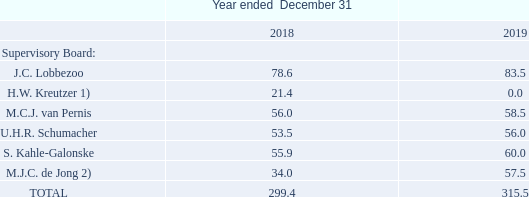SUPERVISORY BOARD
The following table sets forth information concerning all remuneration (base compensation, no bonuses or pensions were paid) from the Company (including its subsidiaries) for services in all capacities to all current and former members of the Supervisory Board of the Company:
1 Period January 1 to May 28, 2018
2 Period as of May 28, 2018
The remuneration of members of the Supervisory Board has been determined by the 2018 Annual General Meeting of Shareholders.
No stock options or performance shares have been granted to members of the Supervisory Board.
How were the remuneration figures determined? By the 2018 annual general meeting of shareholders. What does the table show? Information concerning all remuneration (base compensation, no bonuses or pensions were paid) from the company (including its subsidiaries) for services in all capacities to all current and former members of the supervisory board of the company. Who are the members of the Supervisory board? J.c. lobbezoo, h.w. kreutzer, m.c.j. van pernis, u.h.r. schumacher, s. kahle-galonske, m.j.c. de jong. In 2019, who are the members that received more than 60.0 in remuneration? For Col4 rows 4 to 9 find the values that are >60.0 and the corresponding member in col2
Answer: j.c. lobbezoo. For 2018, what is the order of the members arranged by ascending order in terms of remuneration? Sort the values in Col3 rows 4 to 9 in ascending order
Answer: h.w. kreutzer, m.j.c. de jong, u.h.r. schumacher, s. kahle-galonske, m.c.j. van pernis, j.c. lobbezoo. What is the percentage change in total remuneration from 2018 to 2019?
Answer scale should be: percent.  (315.5 - 299.4 )/ 299.4 
Answer: 5.38. 